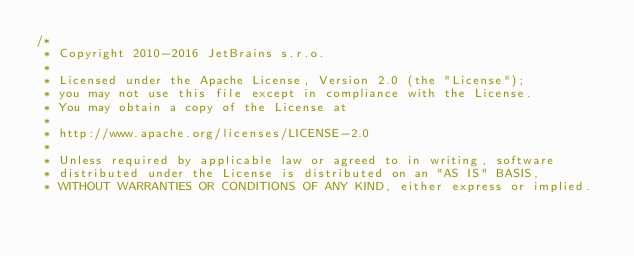Convert code to text. <code><loc_0><loc_0><loc_500><loc_500><_Kotlin_>/*
 * Copyright 2010-2016 JetBrains s.r.o.
 *
 * Licensed under the Apache License, Version 2.0 (the "License");
 * you may not use this file except in compliance with the License.
 * You may obtain a copy of the License at
 *
 * http://www.apache.org/licenses/LICENSE-2.0
 *
 * Unless required by applicable law or agreed to in writing, software
 * distributed under the License is distributed on an "AS IS" BASIS,
 * WITHOUT WARRANTIES OR CONDITIONS OF ANY KIND, either express or implied.</code> 